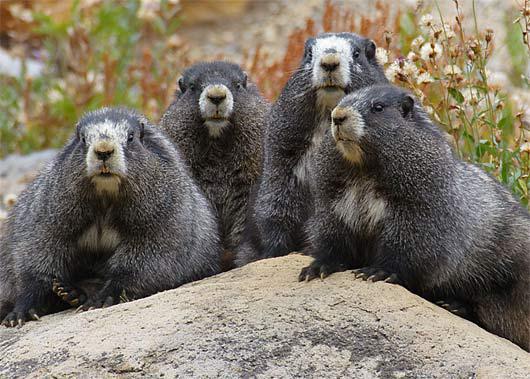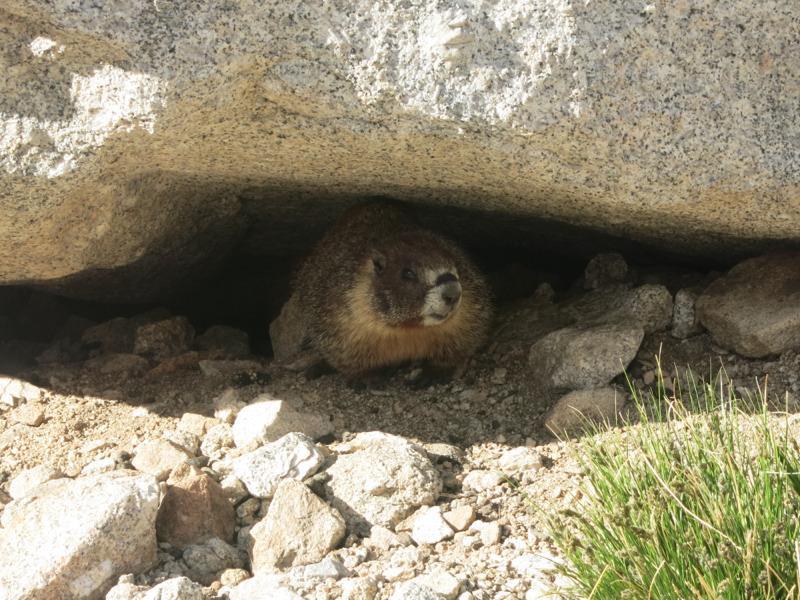The first image is the image on the left, the second image is the image on the right. Assess this claim about the two images: "There are two rodents out in the open.". Correct or not? Answer yes or no. No. The first image is the image on the left, the second image is the image on the right. For the images displayed, is the sentence "There is exactly two rodents." factually correct? Answer yes or no. No. 